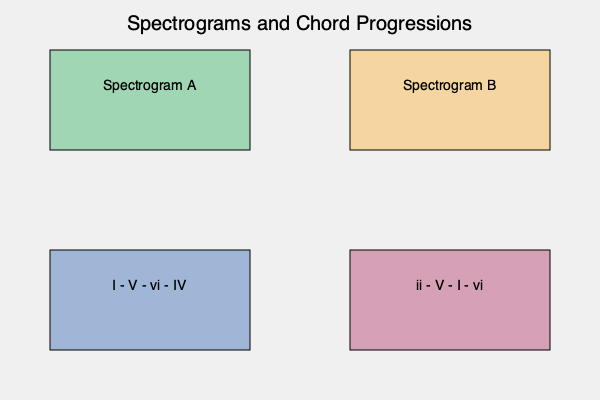Match the spectrograms (A and B) to their corresponding chord progressions (1 and 2) based on the harmonic complexity and frequency distribution typically associated with these progressions. What is the correct pairing? To match the spectrograms with the chord progressions, we need to consider the harmonic complexity and frequency distribution of each progression:

1. Analyze the chord progressions:
   a) Progression 1 (I - V - vi - IV) is a common pop progression with moderate complexity.
   b) Progression 2 (ii - V - I - vi) is a jazz-influenced progression with higher complexity.

2. Examine the spectrograms:
   a) Spectrogram A shows a simpler frequency distribution with fewer overtones.
   b) Spectrogram B displays a more complex pattern with richer harmonics.

3. Match based on complexity:
   a) The simpler Spectrogram A likely corresponds to the more straightforward Progression 1.
   b) The more complex Spectrogram B likely represents the jazzier Progression 2.

4. Consider harmonic implications:
   a) Progression 1's I - V - vi - IV creates a predictable harmonic pattern.
   b) Progression 2's ii - V - I - vi introduces more harmonic tension and resolution.

5. Frequency distribution analysis:
   a) Progression 1 would have more consistent lower frequencies due to its simplicity.
   b) Progression 2 would show more varied frequency content across the spectrum.

Therefore, the correct pairing is Spectrogram A with Chord Progression 1, and Spectrogram B with Chord Progression 2.
Answer: A-1, B-2 